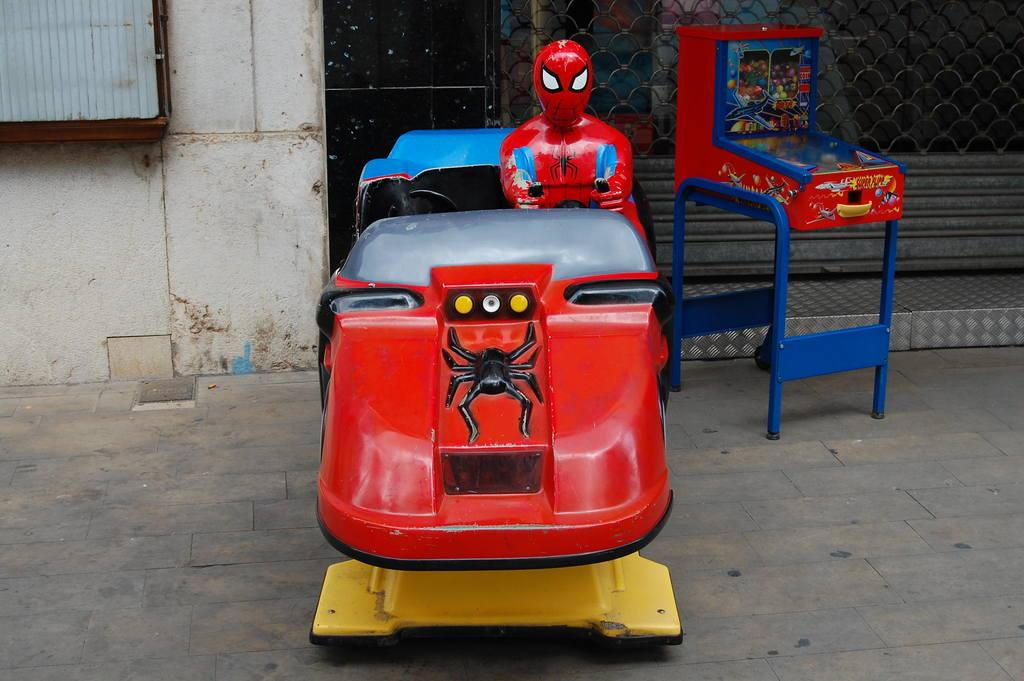What is on the floor in the image? There are toys on the floor. What can be seen in the background of the image? There is a wall and a grille in the background of the image. Are there any other objects visible in the background? Yes, there are other objects visible in the background. What is the cause of death for the father in the image? There is no father or death present in the image. Can you see a squirrel in the image? There is no squirrel present in the image. 